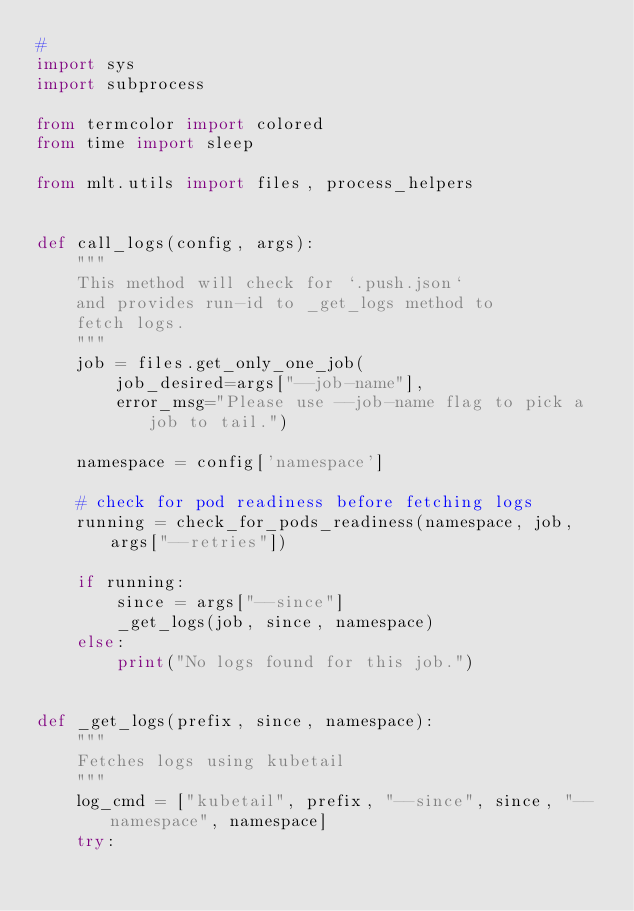Convert code to text. <code><loc_0><loc_0><loc_500><loc_500><_Python_>#
import sys
import subprocess

from termcolor import colored
from time import sleep

from mlt.utils import files, process_helpers


def call_logs(config, args):
    """
    This method will check for `.push.json`
    and provides run-id to _get_logs method to
    fetch logs.
    """
    job = files.get_only_one_job(
        job_desired=args["--job-name"],
        error_msg="Please use --job-name flag to pick a job to tail.")

    namespace = config['namespace']

    # check for pod readiness before fetching logs
    running = check_for_pods_readiness(namespace, job, args["--retries"])

    if running:
        since = args["--since"]
        _get_logs(job, since, namespace)
    else:
        print("No logs found for this job.")


def _get_logs(prefix, since, namespace):
    """
    Fetches logs using kubetail
    """
    log_cmd = ["kubetail", prefix, "--since", since, "--namespace", namespace]
    try:</code> 